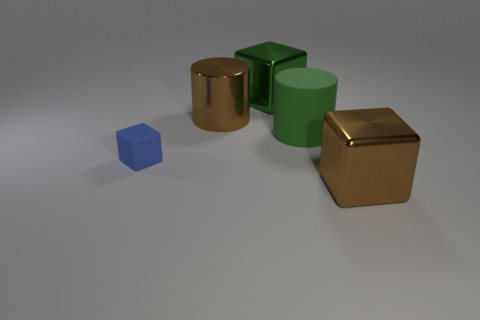What is the shape of the green metallic thing behind the green thing that is on the right side of the big metal cube behind the tiny blue rubber object?
Your answer should be very brief. Cube. There is a object in front of the small blue thing; what is its shape?
Your response must be concise. Cube. Do the brown cylinder and the block that is left of the metallic cylinder have the same material?
Your answer should be compact. No. How many other things are the same shape as the blue thing?
Your answer should be very brief. 2. Do the large shiny cylinder and the shiny thing right of the matte cylinder have the same color?
Ensure brevity in your answer.  Yes. Is there anything else that has the same material as the tiny cube?
Keep it short and to the point. Yes. There is a thing that is on the left side of the brown metallic object that is behind the brown cube; what is its shape?
Your response must be concise. Cube. There is a metallic object that is the same color as the metal cylinder; what size is it?
Ensure brevity in your answer.  Large. Does the large metal object that is in front of the small rubber block have the same shape as the blue matte thing?
Offer a very short reply. Yes. Are there more tiny blue matte cubes that are behind the large brown shiny cylinder than large rubber cylinders in front of the tiny matte object?
Ensure brevity in your answer.  No. 